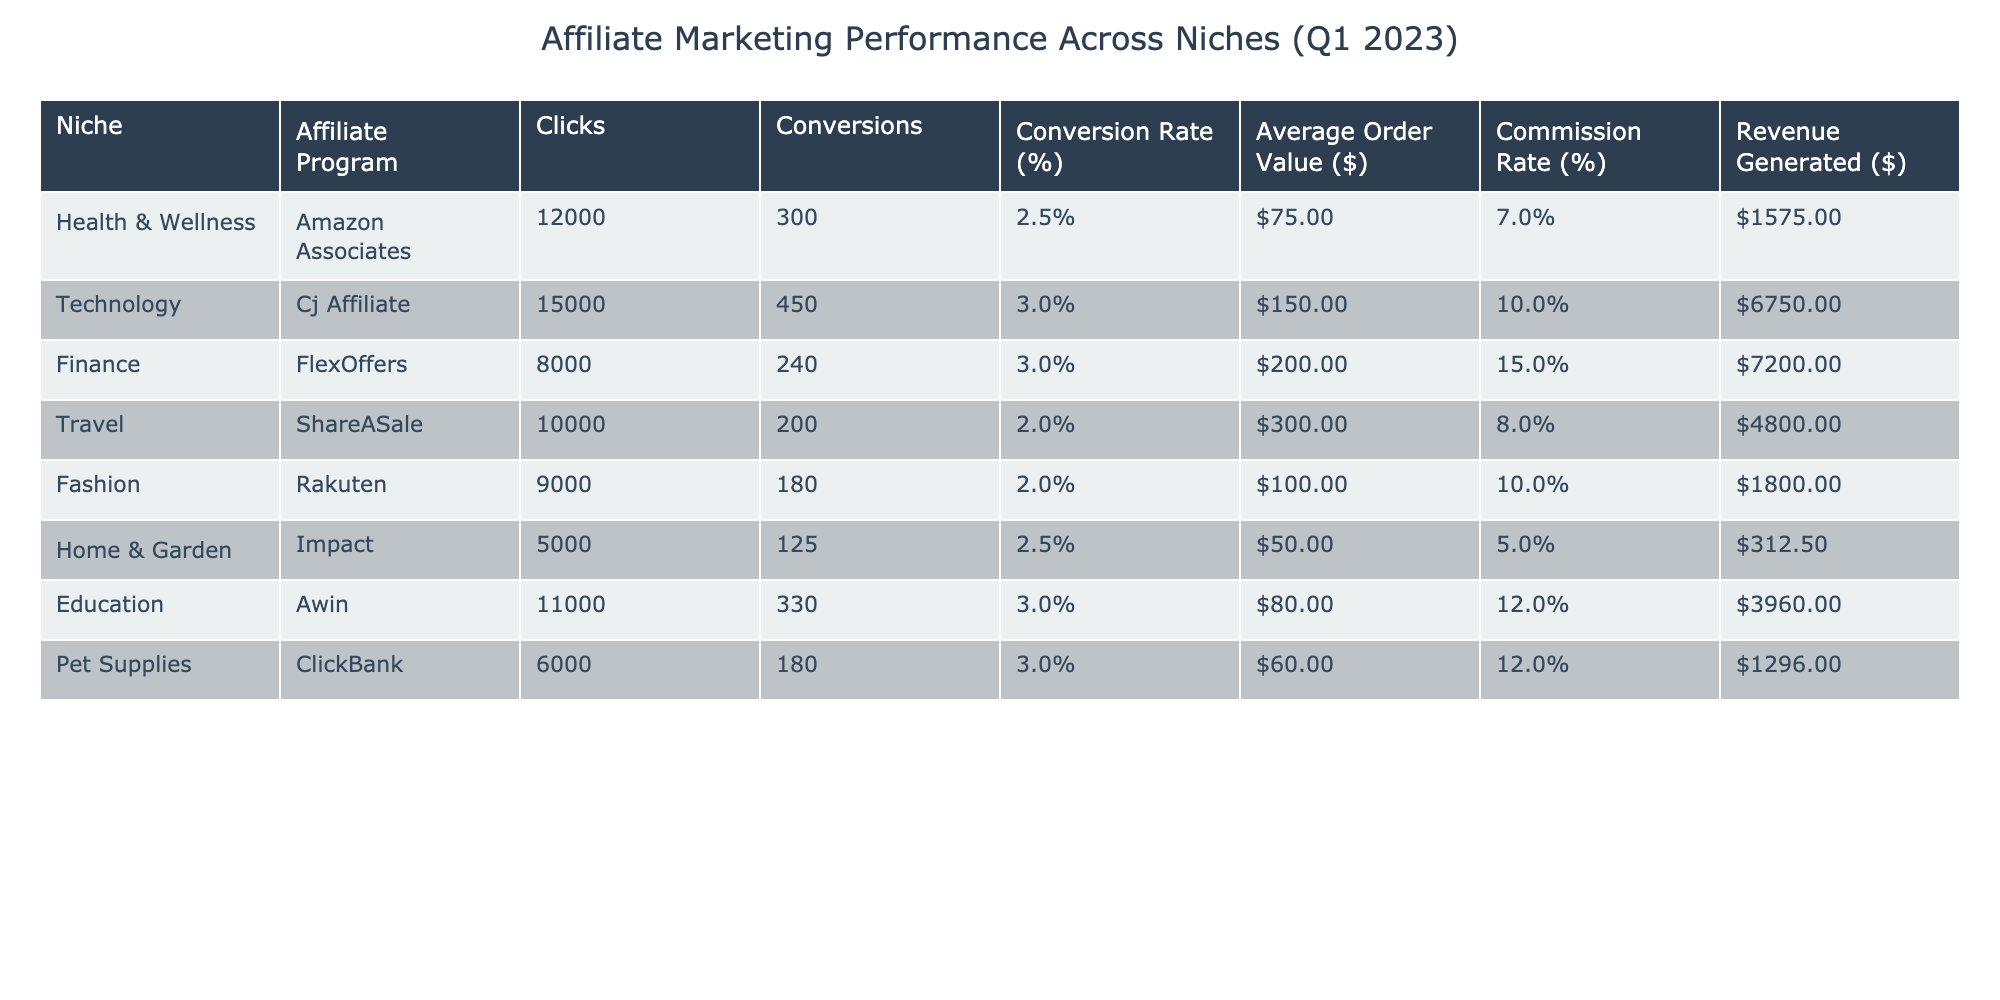What is the highest revenue generated among the niches? Looking at the "Revenue Generated ($)" column, the highest value belongs to the "Technology" niche with $6750.
Answer: $6750 What is the conversion rate for the "Health & Wellness" niche? The "Conversion Rate (%)" for "Health & Wellness" is directly listed in the table as 2.5%.
Answer: 2.5% Which niche has the lowest conversion rate? Scanning the "Conversion Rate (%)" column, "Travel" niche has the lowest conversion rate at 2.0%.
Answer: Travel What is the average revenue generated across all niches? Summing the revenue values: 1575 + 6750 + 7200 + 4800 + 1800 + 312.5 + 3960 + 1296 = 24000. Dividing this by the number of niches (8) gives an average of 24000 / 8 = 3000.
Answer: $3000 Is the conversion rate for the "Fashion" niche higher than for the "Home & Garden" niche? The "Fashion" niche has a conversion rate of 2.0%, and the "Home & Garden" niche also has a conversion rate of 2.5%. Since 2.0% is less than 2.5%, the statement is false.
Answer: No Which affiliate program had the most clicks? The "Technology" niche's affiliate program, "Cj Affiliate," recorded the most clicks at 15000.
Answer: 15000 What is the total revenue generated from the "Finance" and "Education" niches combined? The revenue generated from "Finance" is $7200 and from "Education" is $3960. Adding these amounts gives $7200 + $3960 = $11160.
Answer: $11160 Which niche has the highest average order value, and what is that value? The "Travel" niche has the highest average order value of $300, as shown in the "Average Order Value ($)" column.
Answer: $300 